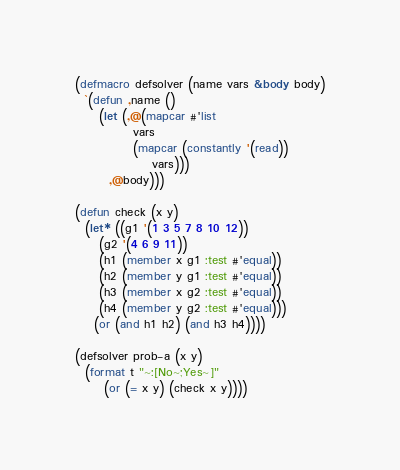<code> <loc_0><loc_0><loc_500><loc_500><_Lisp_>(defmacro defsolver (name vars &body body)
  `(defun ,name ()
     (let (,@(mapcar #'list
		    vars
		    (mapcar (constantly '(read))
			    vars)))
       ,@body)))

(defun check (x y)
  (let* ((g1 '(1 3 5 7 8 10 12))
	 (g2 '(4 6 9 11))
	 (h1 (member x g1 :test #'equal))
	 (h2 (member y g1 :test #'equal))
	 (h3 (member x g2 :test #'equal))
	 (h4 (member y g2 :test #'equal)))
    (or (and h1 h2) (and h3 h4))))

(defsolver prob-a (x y)
  (format t "~:[No~;Yes~]"
	  (or (= x y) (check x y))))
</code> 